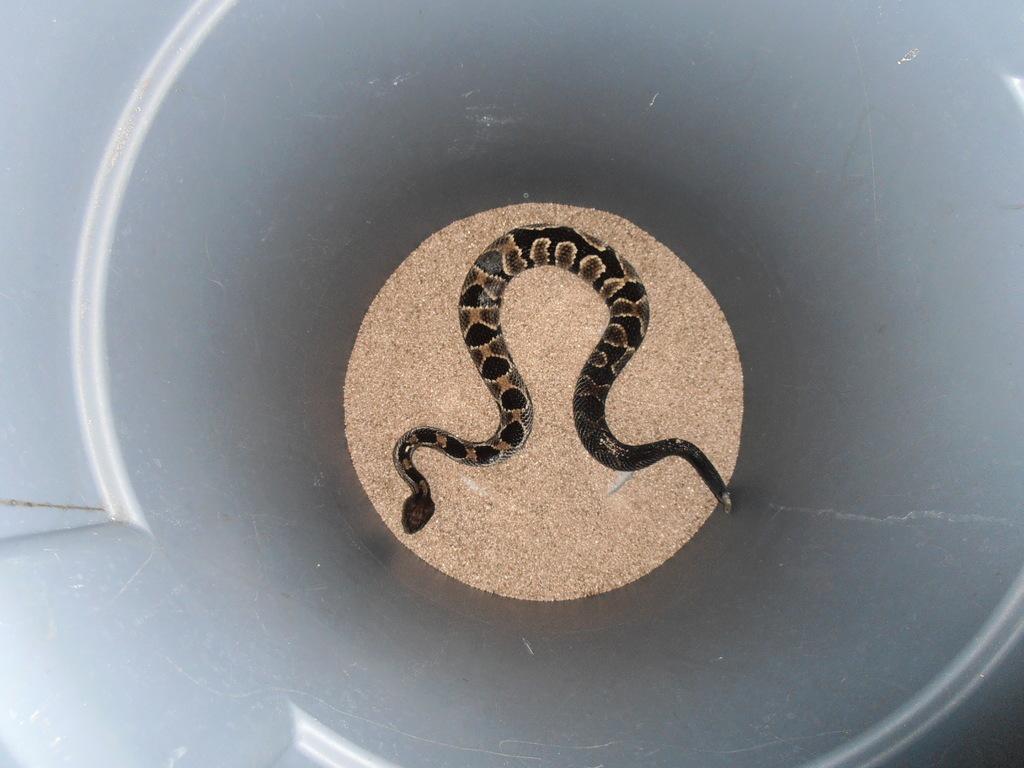Describe this image in one or two sentences. In this picture we can see a container and in a container we can see the sand and a snake. 